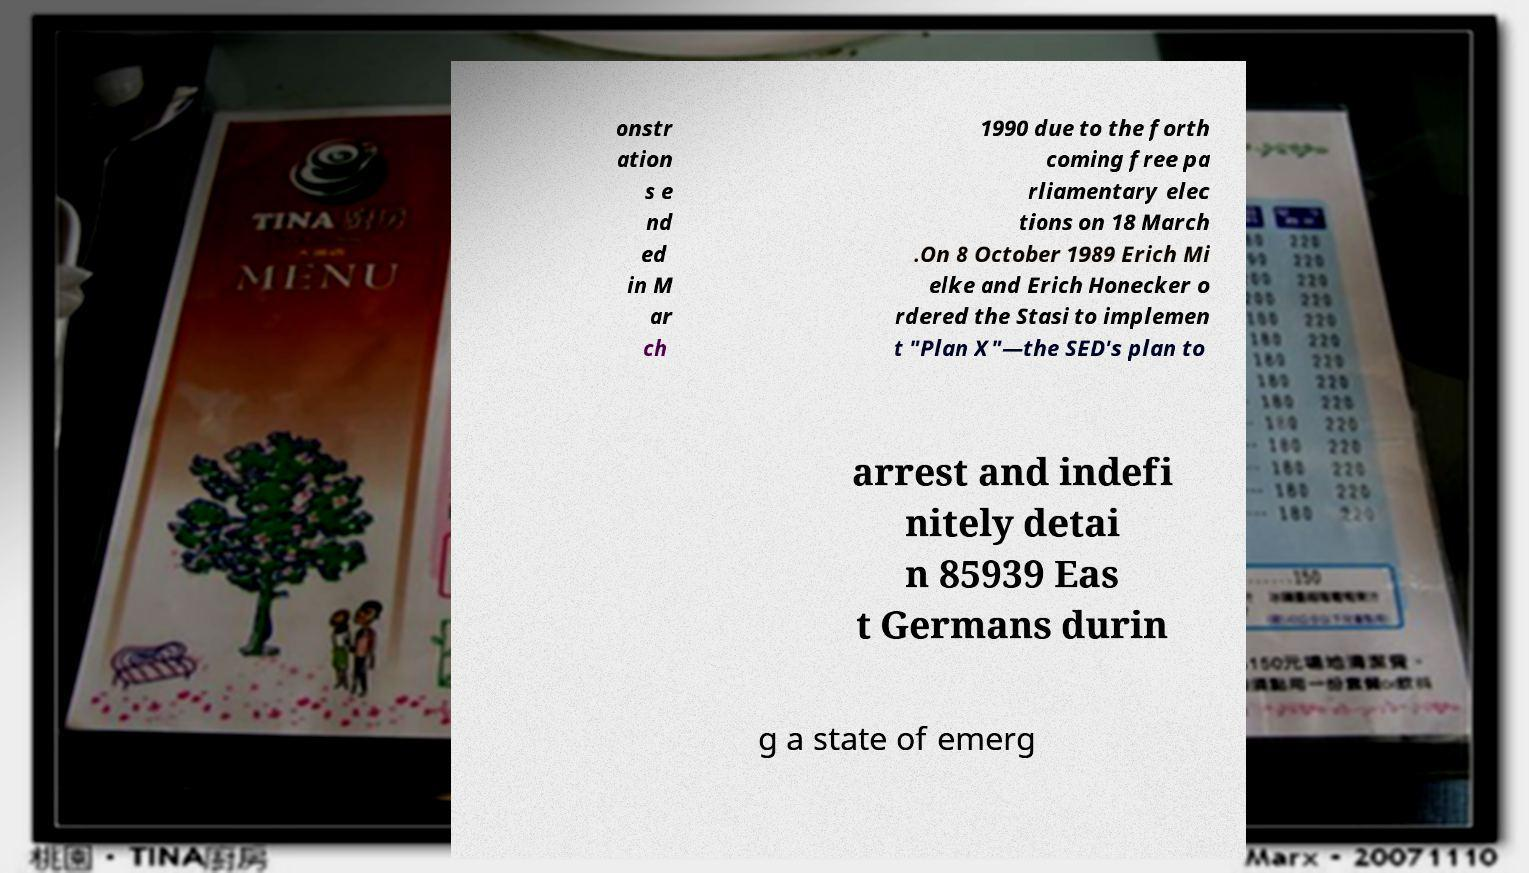I need the written content from this picture converted into text. Can you do that? onstr ation s e nd ed in M ar ch 1990 due to the forth coming free pa rliamentary elec tions on 18 March .On 8 October 1989 Erich Mi elke and Erich Honecker o rdered the Stasi to implemen t "Plan X"—the SED's plan to arrest and indefi nitely detai n 85939 Eas t Germans durin g a state of emerg 